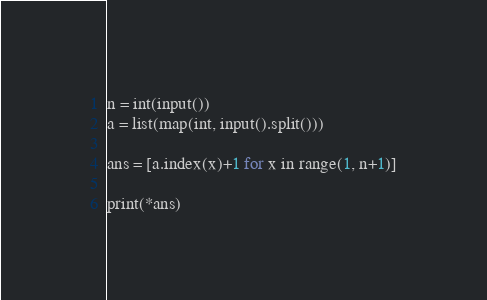Convert code to text. <code><loc_0><loc_0><loc_500><loc_500><_Python_>n = int(input())
a = list(map(int, input().split()))

ans = [a.index(x)+1 for x in range(1, n+1)]

print(*ans)</code> 